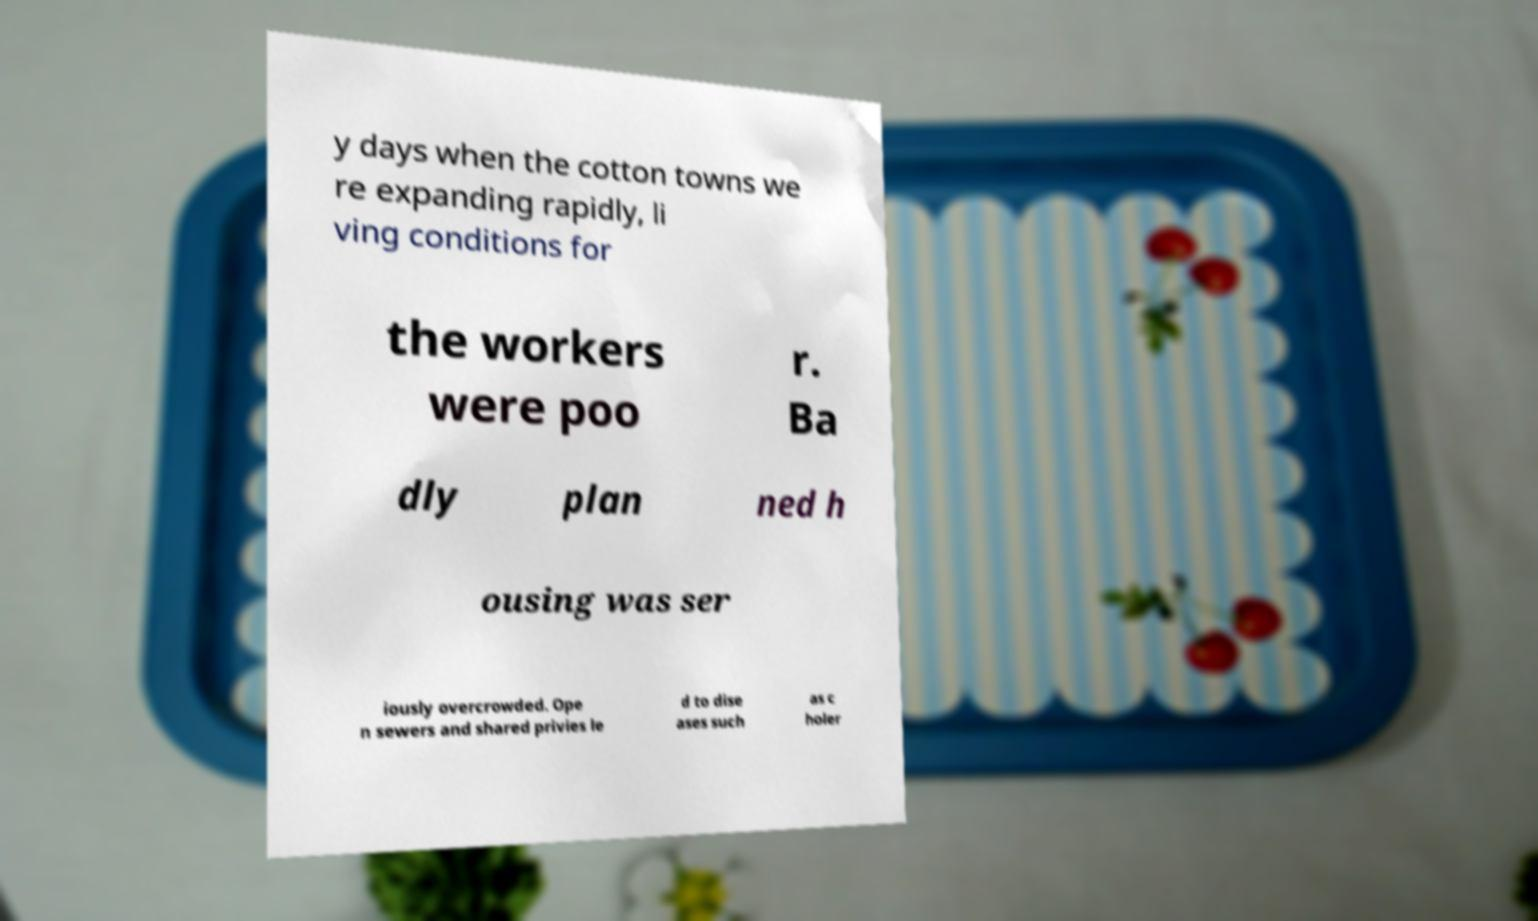There's text embedded in this image that I need extracted. Can you transcribe it verbatim? y days when the cotton towns we re expanding rapidly, li ving conditions for the workers were poo r. Ba dly plan ned h ousing was ser iously overcrowded. Ope n sewers and shared privies le d to dise ases such as c holer 